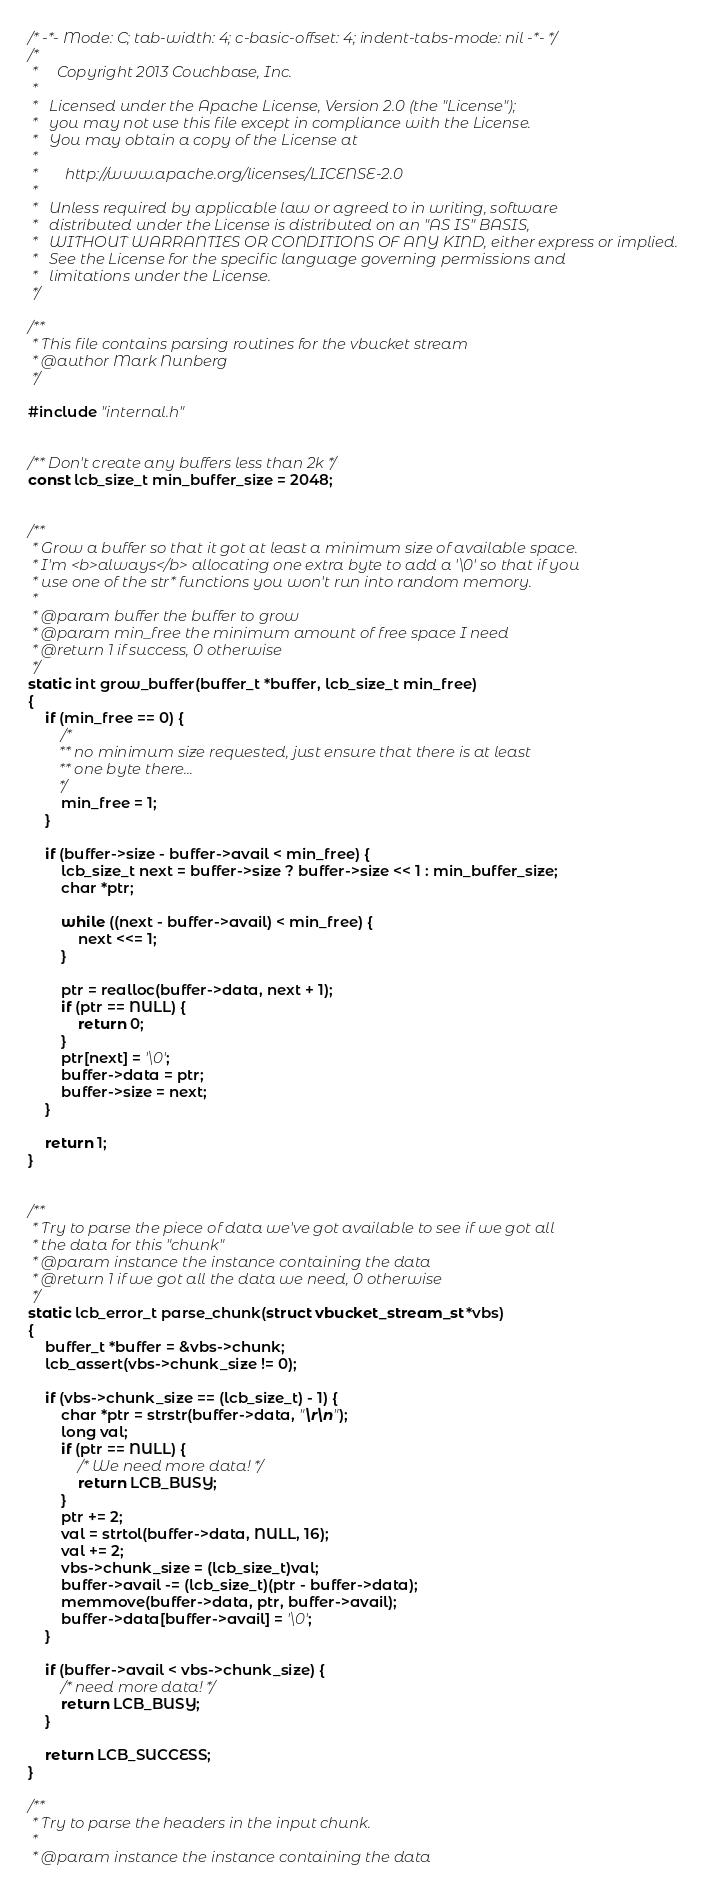Convert code to text. <code><loc_0><loc_0><loc_500><loc_500><_C_>/* -*- Mode: C; tab-width: 4; c-basic-offset: 4; indent-tabs-mode: nil -*- */
/*
 *     Copyright 2013 Couchbase, Inc.
 *
 *   Licensed under the Apache License, Version 2.0 (the "License");
 *   you may not use this file except in compliance with the License.
 *   You may obtain a copy of the License at
 *
 *       http://www.apache.org/licenses/LICENSE-2.0
 *
 *   Unless required by applicable law or agreed to in writing, software
 *   distributed under the License is distributed on an "AS IS" BASIS,
 *   WITHOUT WARRANTIES OR CONDITIONS OF ANY KIND, either express or implied.
 *   See the License for the specific language governing permissions and
 *   limitations under the License.
 */

/**
 * This file contains parsing routines for the vbucket stream
 * @author Mark Nunberg
 */

#include "internal.h"


/** Don't create any buffers less than 2k */
const lcb_size_t min_buffer_size = 2048;


/**
 * Grow a buffer so that it got at least a minimum size of available space.
 * I'm <b>always</b> allocating one extra byte to add a '\0' so that if you
 * use one of the str* functions you won't run into random memory.
 *
 * @param buffer the buffer to grow
 * @param min_free the minimum amount of free space I need
 * @return 1 if success, 0 otherwise
 */
static int grow_buffer(buffer_t *buffer, lcb_size_t min_free)
{
    if (min_free == 0) {
        /*
        ** no minimum size requested, just ensure that there is at least
        ** one byte there...
        */
        min_free = 1;
    }

    if (buffer->size - buffer->avail < min_free) {
        lcb_size_t next = buffer->size ? buffer->size << 1 : min_buffer_size;
        char *ptr;

        while ((next - buffer->avail) < min_free) {
            next <<= 1;
        }

        ptr = realloc(buffer->data, next + 1);
        if (ptr == NULL) {
            return 0;
        }
        ptr[next] = '\0';
        buffer->data = ptr;
        buffer->size = next;
    }

    return 1;
}


/**
 * Try to parse the piece of data we've got available to see if we got all
 * the data for this "chunk"
 * @param instance the instance containing the data
 * @return 1 if we got all the data we need, 0 otherwise
 */
static lcb_error_t parse_chunk(struct vbucket_stream_st *vbs)
{
    buffer_t *buffer = &vbs->chunk;
    lcb_assert(vbs->chunk_size != 0);

    if (vbs->chunk_size == (lcb_size_t) - 1) {
        char *ptr = strstr(buffer->data, "\r\n");
        long val;
        if (ptr == NULL) {
            /* We need more data! */
            return LCB_BUSY;
        }
        ptr += 2;
        val = strtol(buffer->data, NULL, 16);
        val += 2;
        vbs->chunk_size = (lcb_size_t)val;
        buffer->avail -= (lcb_size_t)(ptr - buffer->data);
        memmove(buffer->data, ptr, buffer->avail);
        buffer->data[buffer->avail] = '\0';
    }

    if (buffer->avail < vbs->chunk_size) {
        /* need more data! */
        return LCB_BUSY;
    }

    return LCB_SUCCESS;
}

/**
 * Try to parse the headers in the input chunk.
 *
 * @param instance the instance containing the data</code> 